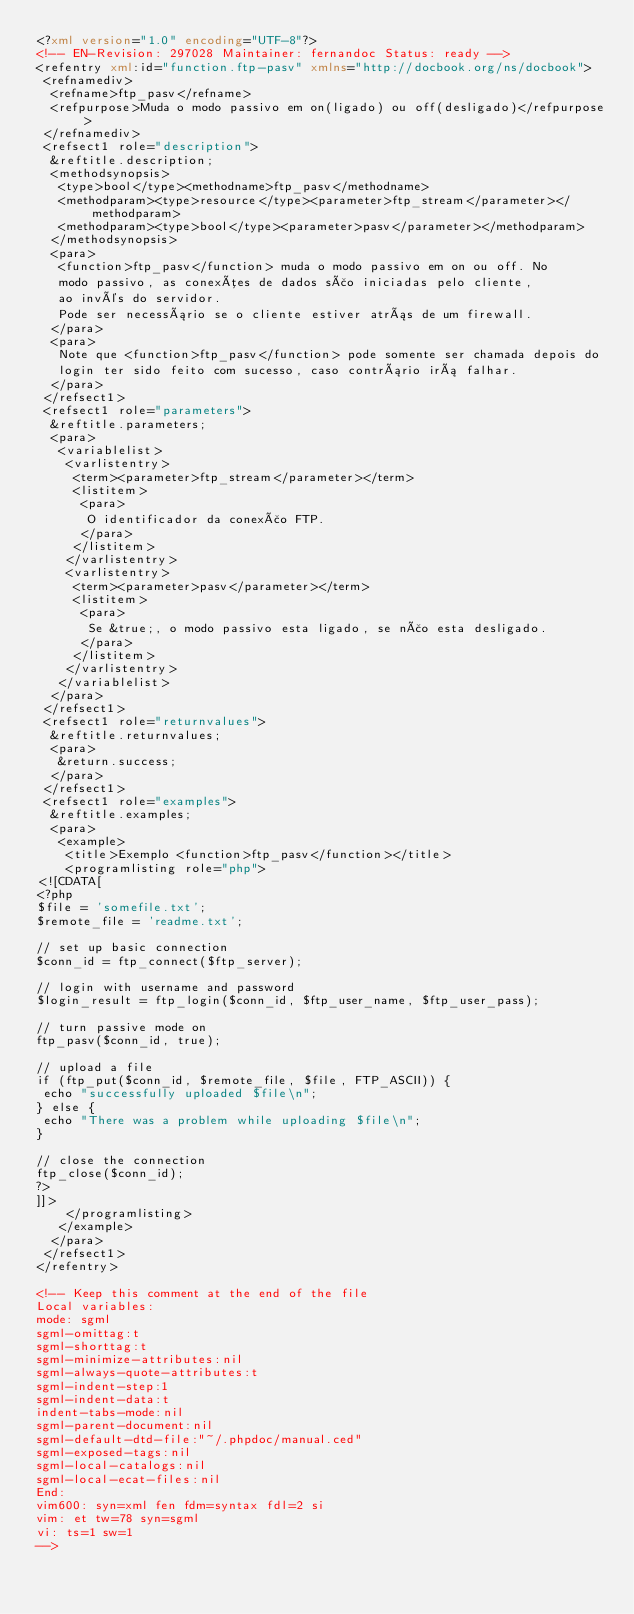Convert code to text. <code><loc_0><loc_0><loc_500><loc_500><_XML_><?xml version="1.0" encoding="UTF-8"?>
<!-- EN-Revision: 297028 Maintainer: fernandoc Status: ready -->
<refentry xml:id="function.ftp-pasv" xmlns="http://docbook.org/ns/docbook">
 <refnamediv>
  <refname>ftp_pasv</refname>
  <refpurpose>Muda o modo passivo em on(ligado) ou off(desligado)</refpurpose>
 </refnamediv>
 <refsect1 role="description">
  &reftitle.description;
  <methodsynopsis>
   <type>bool</type><methodname>ftp_pasv</methodname>
   <methodparam><type>resource</type><parameter>ftp_stream</parameter></methodparam>
   <methodparam><type>bool</type><parameter>pasv</parameter></methodparam>
  </methodsynopsis>
  <para>
   <function>ftp_pasv</function> muda o modo passivo em on ou off. No
   modo passivo, as conexões de dados são iniciadas pelo cliente,
   ao invés do servidor.
   Pode ser necessário se o cliente estiver atrás de um firewall.
  </para>
  <para>
   Note que <function>ftp_pasv</function> pode somente ser chamada depois do
   login ter sido feito com sucesso, caso contrário irá falhar.
  </para>
 </refsect1>
 <refsect1 role="parameters">
  &reftitle.parameters;
  <para>
   <variablelist>
    <varlistentry>
     <term><parameter>ftp_stream</parameter></term>
     <listitem>
      <para>
       O identificador da conexão FTP.
      </para>
     </listitem>
    </varlistentry>
    <varlistentry>
     <term><parameter>pasv</parameter></term>
     <listitem>
      <para>
       Se &true;, o modo passivo esta ligado, se não esta desligado.
      </para>
     </listitem>
    </varlistentry>
   </variablelist>
  </para>
 </refsect1>
 <refsect1 role="returnvalues">
  &reftitle.returnvalues;
  <para>
   &return.success;
  </para>
 </refsect1>
 <refsect1 role="examples">
  &reftitle.examples;
  <para>
   <example>
    <title>Exemplo <function>ftp_pasv</function></title>
    <programlisting role="php">
<![CDATA[
<?php
$file = 'somefile.txt';
$remote_file = 'readme.txt';

// set up basic connection
$conn_id = ftp_connect($ftp_server);

// login with username and password
$login_result = ftp_login($conn_id, $ftp_user_name, $ftp_user_pass);

// turn passive mode on
ftp_pasv($conn_id, true);

// upload a file
if (ftp_put($conn_id, $remote_file, $file, FTP_ASCII)) {
 echo "successfully uploaded $file\n";
} else {
 echo "There was a problem while uploading $file\n";
}

// close the connection
ftp_close($conn_id);
?>
]]>
    </programlisting>
   </example>
  </para>
 </refsect1>
</refentry>

<!-- Keep this comment at the end of the file
Local variables:
mode: sgml
sgml-omittag:t
sgml-shorttag:t
sgml-minimize-attributes:nil
sgml-always-quote-attributes:t
sgml-indent-step:1
sgml-indent-data:t
indent-tabs-mode:nil
sgml-parent-document:nil
sgml-default-dtd-file:"~/.phpdoc/manual.ced"
sgml-exposed-tags:nil
sgml-local-catalogs:nil
sgml-local-ecat-files:nil
End:
vim600: syn=xml fen fdm=syntax fdl=2 si
vim: et tw=78 syn=sgml
vi: ts=1 sw=1
-->
</code> 